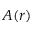Convert formula to latex. <formula><loc_0><loc_0><loc_500><loc_500>A ( r )</formula> 